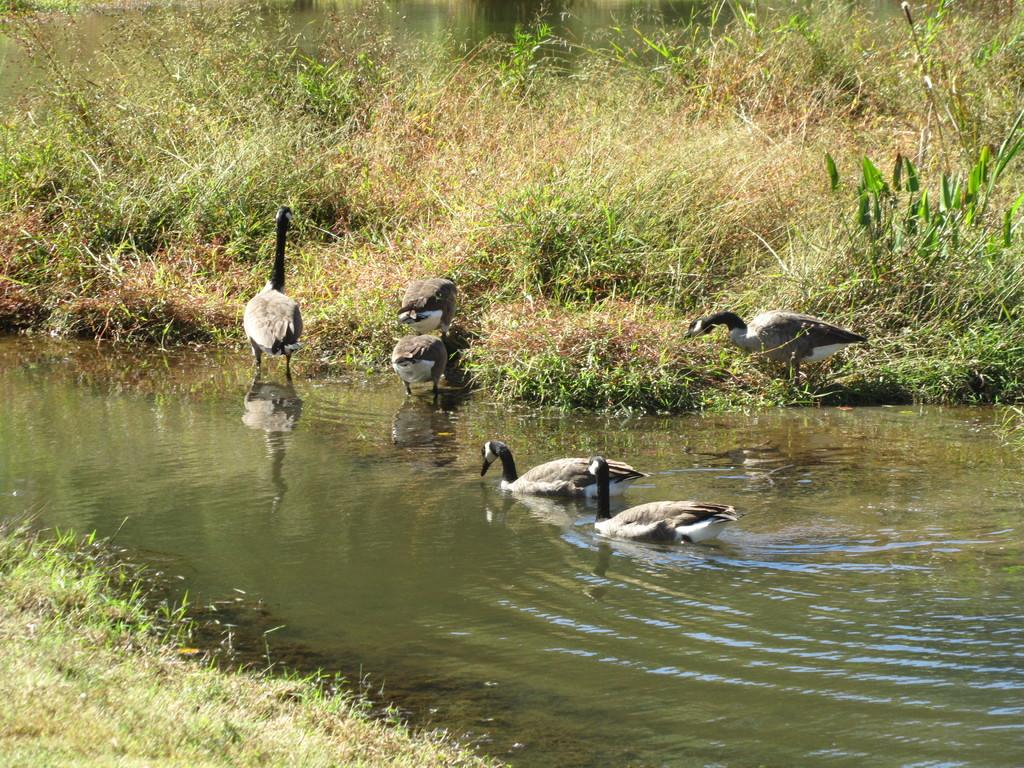What type of animals can be seen in the image? Birds can be seen in the image. What is the primary element in which some of the birds are situated? Some birds are in the water visible in the image. What type of vegetation is present at the top of the image? Plants are present at the top of the image. Where is grass visible in the image? Grass is visible in the left side bottom corner of the image. What type of potato is being grown by the ants in the image? There are no ants or potatoes present in the image. 